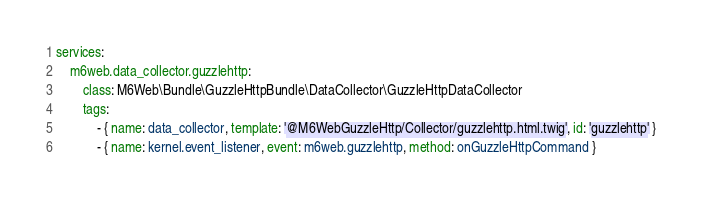<code> <loc_0><loc_0><loc_500><loc_500><_YAML_>services:
    m6web.data_collector.guzzlehttp:
        class: M6Web\Bundle\GuzzleHttpBundle\DataCollector\GuzzleHttpDataCollector
        tags:
            - { name: data_collector, template: '@M6WebGuzzleHttp/Collector/guzzlehttp.html.twig', id: 'guzzlehttp' }
            - { name: kernel.event_listener, event: m6web.guzzlehttp, method: onGuzzleHttpCommand }
</code> 